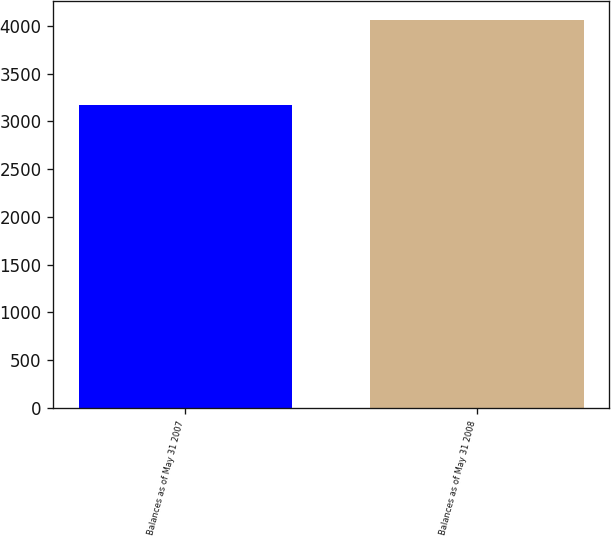<chart> <loc_0><loc_0><loc_500><loc_500><bar_chart><fcel>Balances as of May 31 2007<fcel>Balances as of May 31 2008<nl><fcel>3169<fcel>4058<nl></chart> 